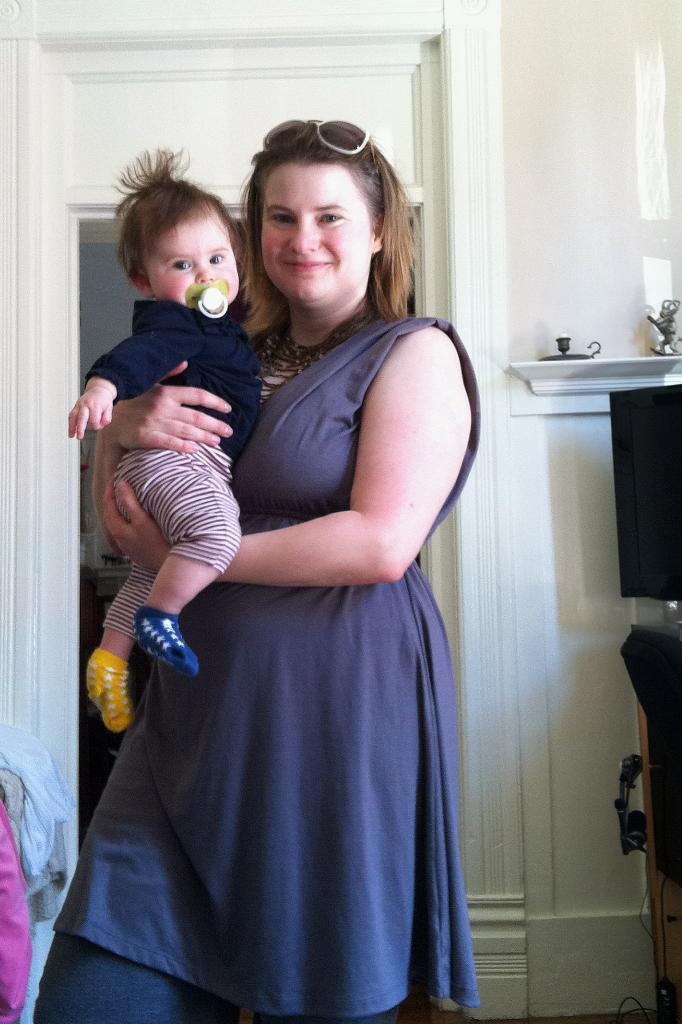Could you give a brief overview of what you see in this image? In this image in the center there is one woman who is standing and smiling, and she is holding one baby and in the background there is a wall. On the right side there is a television and a table, and in the background there is a wall. On the left side there are some clothes. 